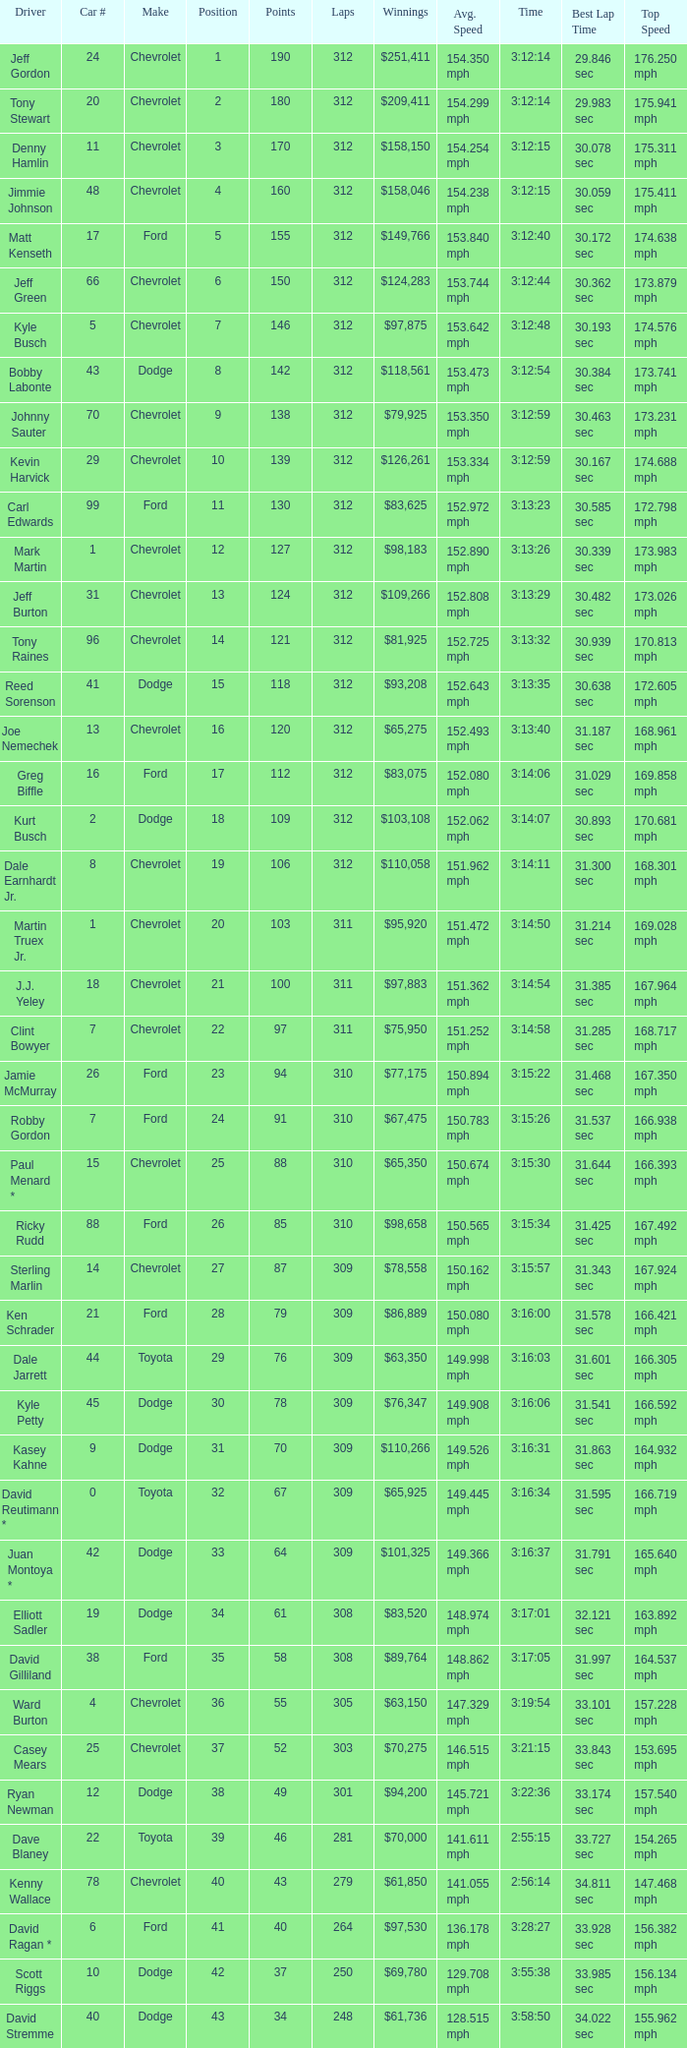What is the sum of laps that has a car number of larger than 1, is a ford, and has 155 points? 312.0. 